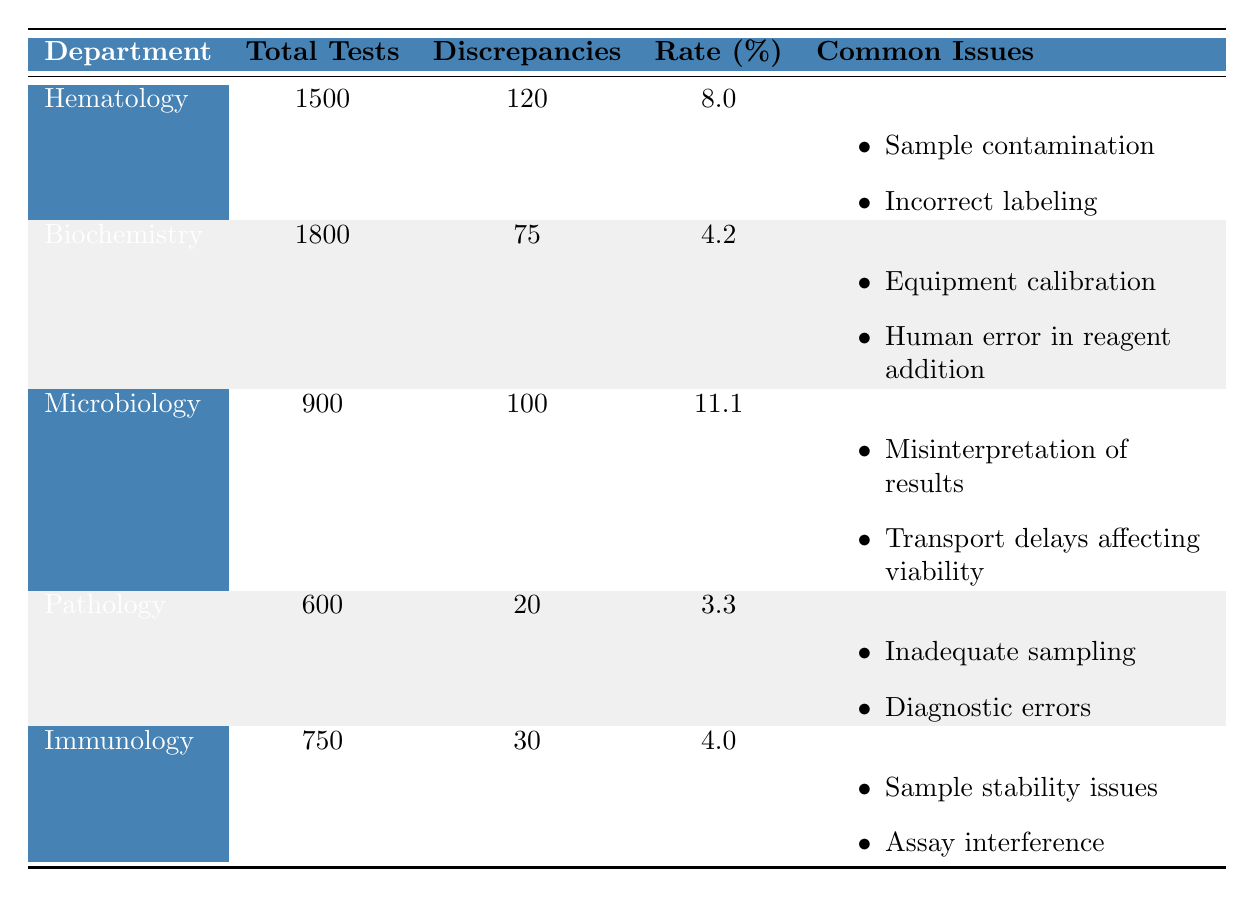What is the discrepancy rate for the Pathology department? The table shows that the discrepancy rate for the Pathology department is directly listed as 3.3%.
Answer: 3.3% Which department has the highest number of discrepancies? By inspecting the column for discrepancies, the Hematology department has the highest number, with 120 discrepancies.
Answer: Hematology What is the total number of tests conducted across all departments? To find the total tests, we sum the total tests for each department: 1500 (Hematology) + 1800 (Biochemistry) + 900 (Microbiology) + 600 (Pathology) + 750 (Immunology) = 4550.
Answer: 4550 Do all departments have sample contamination as a common issue? Reviewing the common issues for each department, only the Hematology department lists sample contamination. Therefore, not all departments have this issue.
Answer: No Which department has the lowest discrepancy rate? The discrepancy rates are as follows: Hematology (8.0), Biochemistry (4.2), Microbiology (11.1), Pathology (3.3), and Immunology (4.0). Pathology has the lowest discrepancy rate at 3.3%.
Answer: Pathology What is the percentage of discrepancies for the Biochemistry department? The table indicates that the Biochemistry department has a discrepancy rate of 4.2%, which is directly stated.
Answer: 4.2% If we combine the discrepancies from Hematology and Microbiology, how does it compare to those from the Biochemistry and Pathology departments combined? The discrepancies for Hematology and Microbiology combined is 120 (Hematology) + 100 (Microbiology) = 220. The combined discrepancies for Biochemistry and Pathology is 75 (Biochemistry) + 20 (Pathology) = 95. Therefore, 220 is greater than 95.
Answer: 220 is greater than 95 Which common issue appears in both the Hematology and Microbiology departments? Hematology mentions sample contamination and incorrect labeling, while Microbiology lists misinterpretation of results and transport delays. There are no common issues listed between them.
Answer: None What is the total percentage of discrepancies if you consider the total tests in the Hematology and Pathology departments combined? Hematology has a total of 1500 tests with 120 discrepancies (8.0%), and Pathology has 600 tests with 20 discrepancies (3.3%). Combined, that's 2100 tests with 140 discrepancies: (140/2100) * 100 = 6.67%.
Answer: 6.67% 